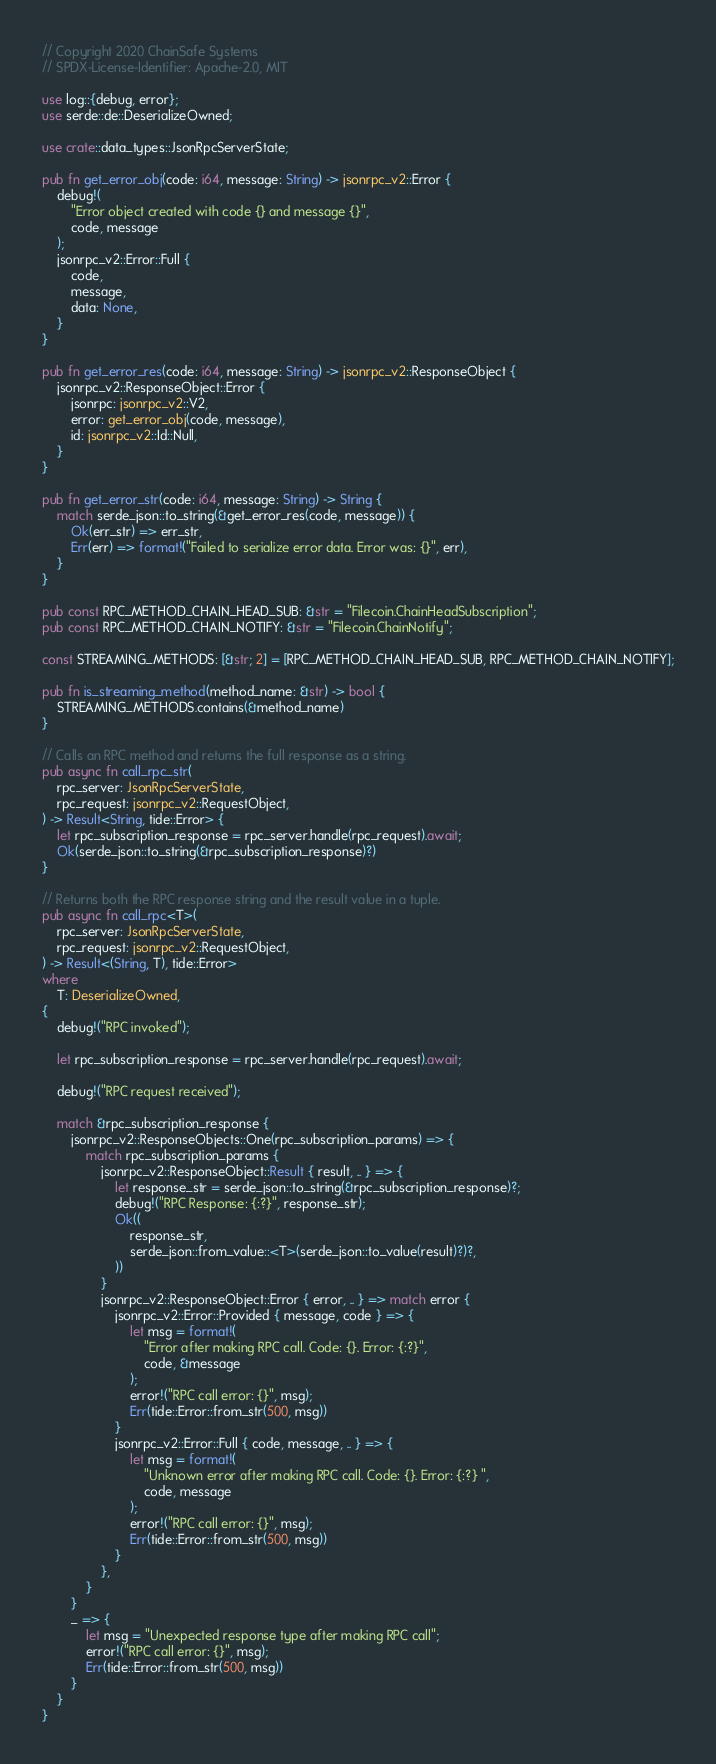<code> <loc_0><loc_0><loc_500><loc_500><_Rust_>// Copyright 2020 ChainSafe Systems
// SPDX-License-Identifier: Apache-2.0, MIT

use log::{debug, error};
use serde::de::DeserializeOwned;

use crate::data_types::JsonRpcServerState;

pub fn get_error_obj(code: i64, message: String) -> jsonrpc_v2::Error {
    debug!(
        "Error object created with code {} and message {}",
        code, message
    );
    jsonrpc_v2::Error::Full {
        code,
        message,
        data: None,
    }
}

pub fn get_error_res(code: i64, message: String) -> jsonrpc_v2::ResponseObject {
    jsonrpc_v2::ResponseObject::Error {
        jsonrpc: jsonrpc_v2::V2,
        error: get_error_obj(code, message),
        id: jsonrpc_v2::Id::Null,
    }
}

pub fn get_error_str(code: i64, message: String) -> String {
    match serde_json::to_string(&get_error_res(code, message)) {
        Ok(err_str) => err_str,
        Err(err) => format!("Failed to serialize error data. Error was: {}", err),
    }
}

pub const RPC_METHOD_CHAIN_HEAD_SUB: &str = "Filecoin.ChainHeadSubscription";
pub const RPC_METHOD_CHAIN_NOTIFY: &str = "Filecoin.ChainNotify";

const STREAMING_METHODS: [&str; 2] = [RPC_METHOD_CHAIN_HEAD_SUB, RPC_METHOD_CHAIN_NOTIFY];

pub fn is_streaming_method(method_name: &str) -> bool {
    STREAMING_METHODS.contains(&method_name)
}

// Calls an RPC method and returns the full response as a string.
pub async fn call_rpc_str(
    rpc_server: JsonRpcServerState,
    rpc_request: jsonrpc_v2::RequestObject,
) -> Result<String, tide::Error> {
    let rpc_subscription_response = rpc_server.handle(rpc_request).await;
    Ok(serde_json::to_string(&rpc_subscription_response)?)
}

// Returns both the RPC response string and the result value in a tuple.
pub async fn call_rpc<T>(
    rpc_server: JsonRpcServerState,
    rpc_request: jsonrpc_v2::RequestObject,
) -> Result<(String, T), tide::Error>
where
    T: DeserializeOwned,
{
    debug!("RPC invoked");

    let rpc_subscription_response = rpc_server.handle(rpc_request).await;

    debug!("RPC request received");

    match &rpc_subscription_response {
        jsonrpc_v2::ResponseObjects::One(rpc_subscription_params) => {
            match rpc_subscription_params {
                jsonrpc_v2::ResponseObject::Result { result, .. } => {
                    let response_str = serde_json::to_string(&rpc_subscription_response)?;
                    debug!("RPC Response: {:?}", response_str);
                    Ok((
                        response_str,
                        serde_json::from_value::<T>(serde_json::to_value(result)?)?,
                    ))
                }
                jsonrpc_v2::ResponseObject::Error { error, .. } => match error {
                    jsonrpc_v2::Error::Provided { message, code } => {
                        let msg = format!(
                            "Error after making RPC call. Code: {}. Error: {:?}",
                            code, &message
                        );
                        error!("RPC call error: {}", msg);
                        Err(tide::Error::from_str(500, msg))
                    }
                    jsonrpc_v2::Error::Full { code, message, .. } => {
                        let msg = format!(
                            "Unknown error after making RPC call. Code: {}. Error: {:?} ",
                            code, message
                        );
                        error!("RPC call error: {}", msg);
                        Err(tide::Error::from_str(500, msg))
                    }
                },
            }
        }
        _ => {
            let msg = "Unexpected response type after making RPC call";
            error!("RPC call error: {}", msg);
            Err(tide::Error::from_str(500, msg))
        }
    }
}
</code> 